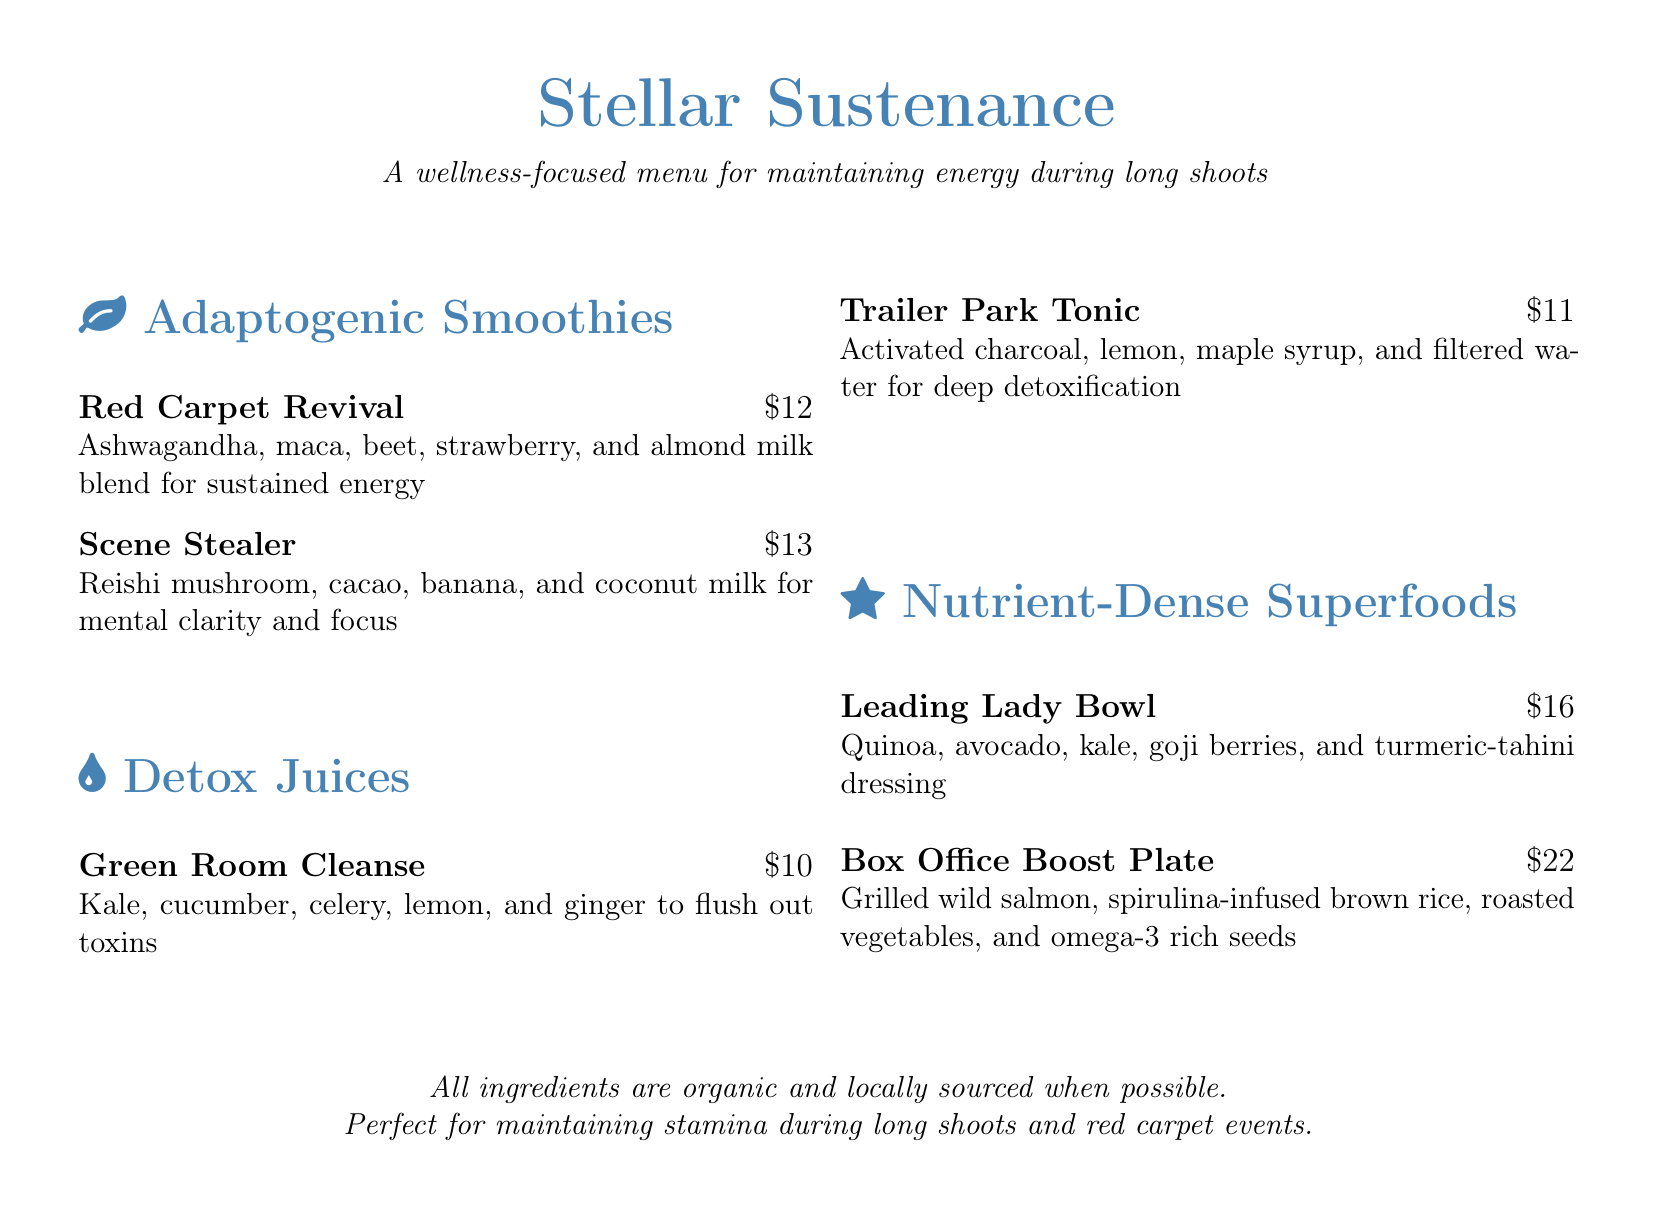What is the name of the detox juice that uses activated charcoal? The detox juice with activated charcoal is titled "Trailer Park Tonic."
Answer: Trailer Park Tonic How much does the "Leading Lady Bowl" cost? The "Leading Lady Bowl" is listed for $16 on the menu.
Answer: $16 Which adaptogenic smoothie contains cacao? The adaptogenic smoothie that includes cacao is called "Scene Stealer."
Answer: Scene Stealer What ingredient is used in both the "Green Room Cleanse" and "Trailer Park Tonic"? Both juices include lemon as an ingredient.
Answer: Lemon Which nutrient-dense superfood dish has grilled wild salmon? The dish with grilled wild salmon is named "Box Office Boost Plate."
Answer: Box Office Boost Plate What is the total number of adaptogenic smoothies listed on the menu? There are a total of 2 adaptogenic smoothies provided in the menu section.
Answer: 2 What type of milk is used in the "Red Carpet Revival" smoothie? The "Red Carpet Revival" smoothie uses almond milk.
Answer: Almond milk Which dish is specifically designed to enhance mental clarity and focus? The dish that enhances mental clarity and focus is the "Scene Stealer."
Answer: Scene Stealer What is mentioned about the ingredients in the menu? The menu states that all ingredients are organic and locally sourced when possible.
Answer: Organic and locally sourced 